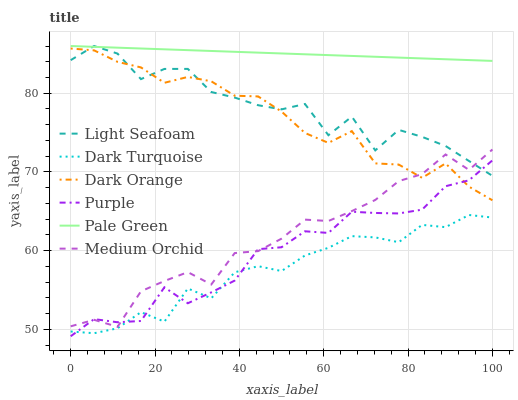Does Dark Turquoise have the minimum area under the curve?
Answer yes or no. Yes. Does Pale Green have the maximum area under the curve?
Answer yes or no. Yes. Does Purple have the minimum area under the curve?
Answer yes or no. No. Does Purple have the maximum area under the curve?
Answer yes or no. No. Is Pale Green the smoothest?
Answer yes or no. Yes. Is Light Seafoam the roughest?
Answer yes or no. Yes. Is Purple the smoothest?
Answer yes or no. No. Is Purple the roughest?
Answer yes or no. No. Does Dark Turquoise have the lowest value?
Answer yes or no. No. Does Light Seafoam have the highest value?
Answer yes or no. Yes. Does Purple have the highest value?
Answer yes or no. No. Is Medium Orchid less than Pale Green?
Answer yes or no. Yes. Is Dark Orange greater than Dark Turquoise?
Answer yes or no. Yes. Does Light Seafoam intersect Purple?
Answer yes or no. Yes. Is Light Seafoam less than Purple?
Answer yes or no. No. Is Light Seafoam greater than Purple?
Answer yes or no. No. Does Medium Orchid intersect Pale Green?
Answer yes or no. No. 